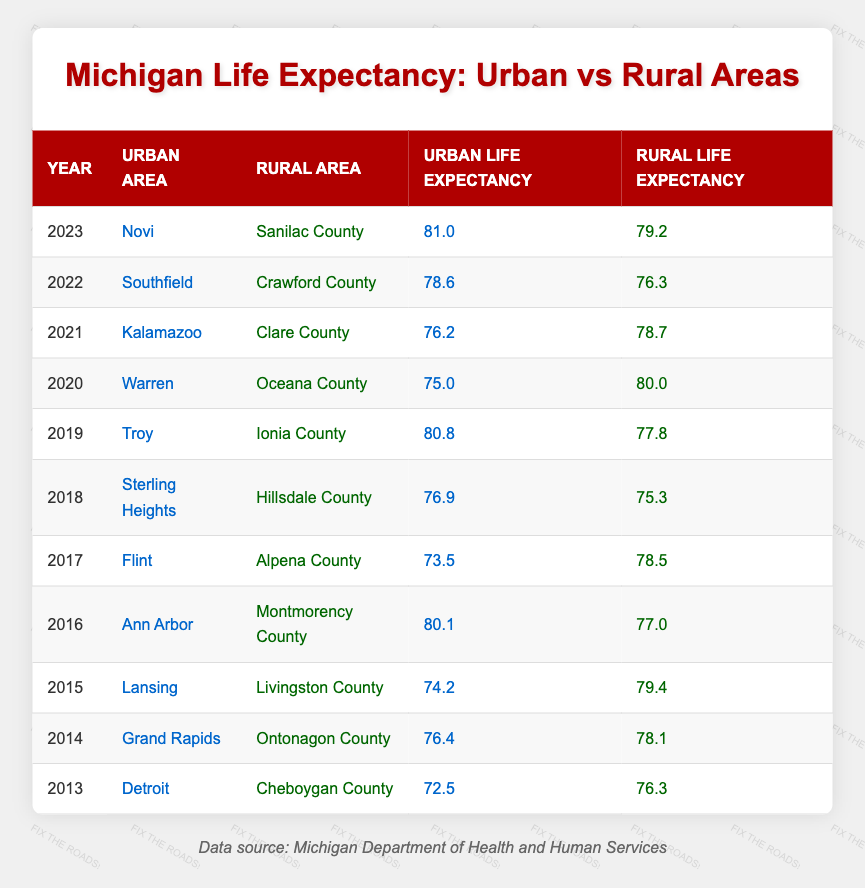What is the highest urban life expectancy recorded in the table? The highest urban life expectancy in the table is found in the year 2023 for Novi, which is 81.0 years. By scanning through the urban life expectancy values in each row, 81.0 is the largest value.
Answer: 81.0 Which rural area had the lowest life expectancy in the table, and what was that value? The lowest rural life expectancy is found in the year 2018 for Hillsdale County, which is 75.3 years. By comparing all rural life expectancy values, 75.3 is the least.
Answer: 75.3 What is the difference in life expectancy between urban and rural areas for the year 2020? In 2020, urban life expectancy was 75.0 years and rural life expectancy was 80.0 years. The difference is calculated as 80.0 - 75.0 = 5.0 years.
Answer: 5.0 Was there ever a year where urban life expectancy exceeded rural life expectancy? If so, which year(s)? Yes, in the years 2016, 2019, and 2023, urban life expectancy exceeded rural life expectancy. Comparing the respective urban and rural figures in those years shows that in 2016 (80.1 vs 77.0), 2019 (80.8 vs 77.8), and 2023 (81.0 vs 79.2), urban figures were higher.
Answer: Yes, in 2016, 2019, and 2023 What was the average urban life expectancy over the 11 years provided? The total urban life expectancy values over the years are 72.5, 76.4, 74.2, 80.1, 73.5, 76.9, 80.8, 75.0, 76.2, 78.6, and 81.0. The sum is  72.5 + 76.4 + 74.2 + 80.1 + 73.5 + 76.9 + 80.8 + 75.0 + 76.2 + 78.6 + 81.0 =  83.6, and dividing by 11 gives an average of 76.45 years.
Answer: 76.45 In which year did the urban life expectancy show the biggest increase from the previous year? The biggest increase occurred from 2018 to 2019, where the urban life expectancy rose from 76.9 to 80.8 years, an increase of 3.9 years. By calculating the difference (80.8 - 76.9), this shows the largest growth between consecutive years.
Answer: 2018 to 2019 